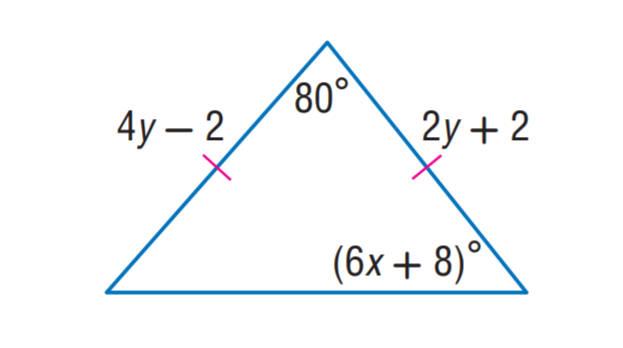Question: Find x.
Choices:
A. 5
B. 7
C. 8
D. 10
Answer with the letter. Answer: B Question: Find y.
Choices:
A. 1
B. 2
C. 3
D. 4
Answer with the letter. Answer: B 